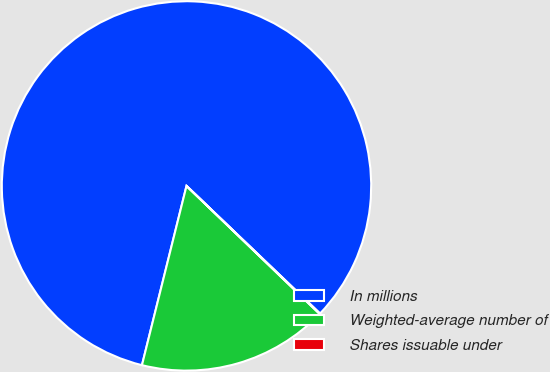<chart> <loc_0><loc_0><loc_500><loc_500><pie_chart><fcel>In millions<fcel>Weighted-average number of<fcel>Shares issuable under<nl><fcel>83.27%<fcel>16.69%<fcel>0.05%<nl></chart> 